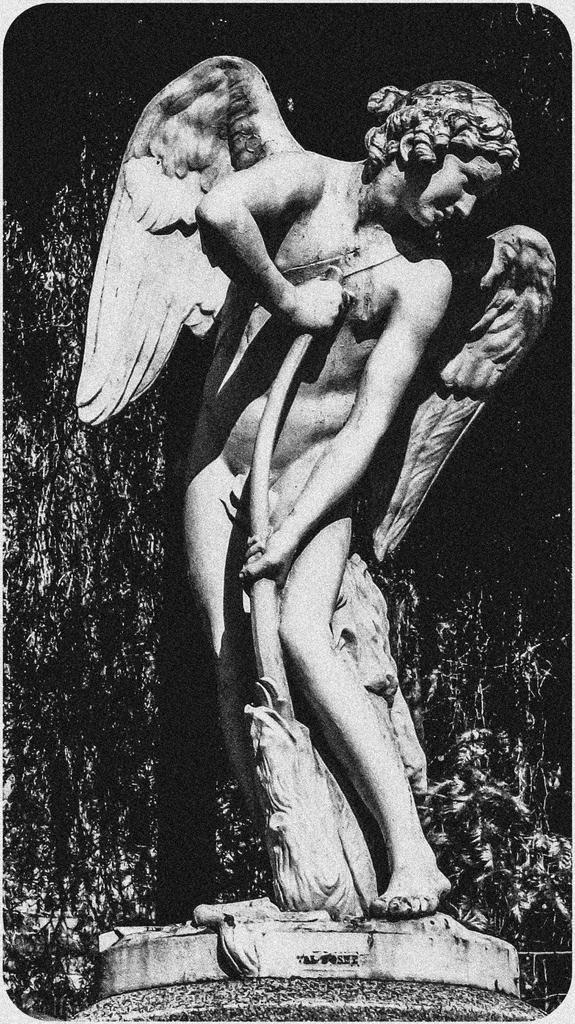In one or two sentences, can you explain what this image depicts? This is a black and white image. In the center of the image we can see a statue. In the background the image is dark. 